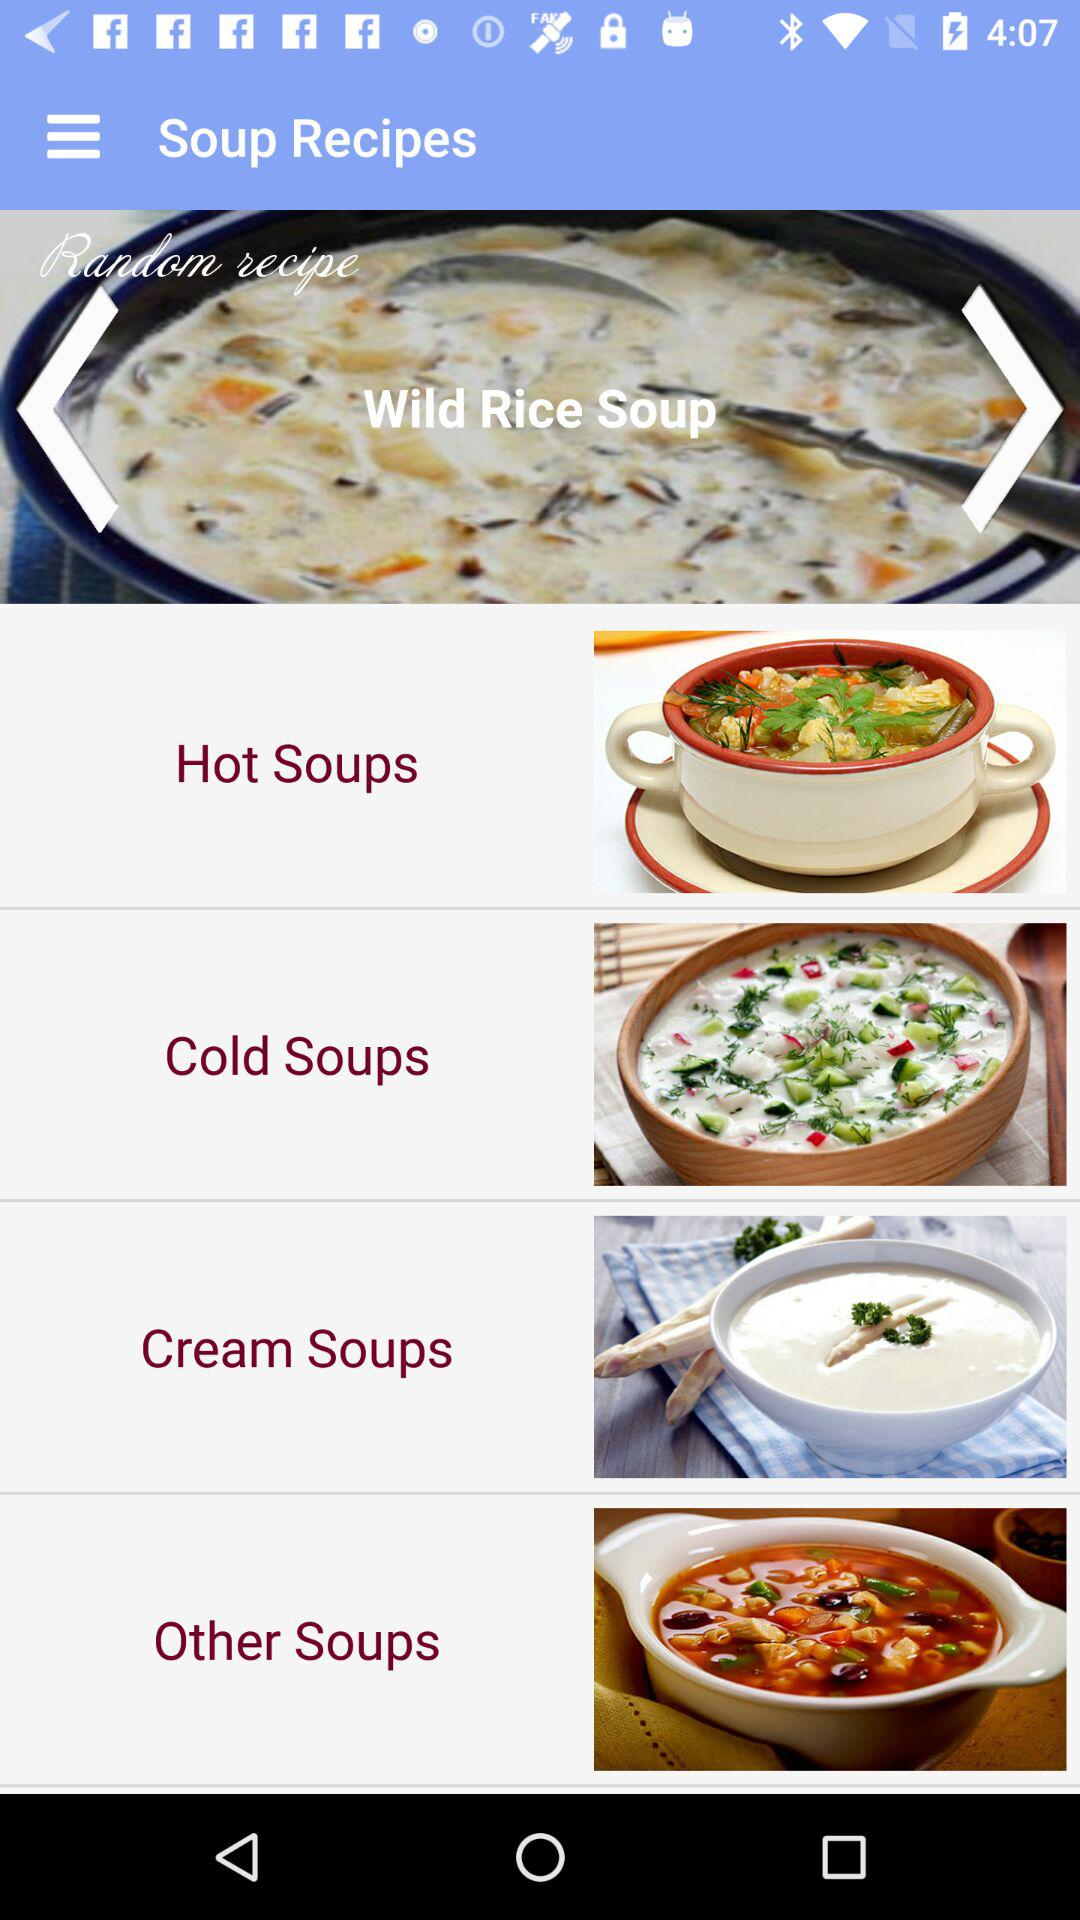What is the application name? The application name is "Soup Recipes". 